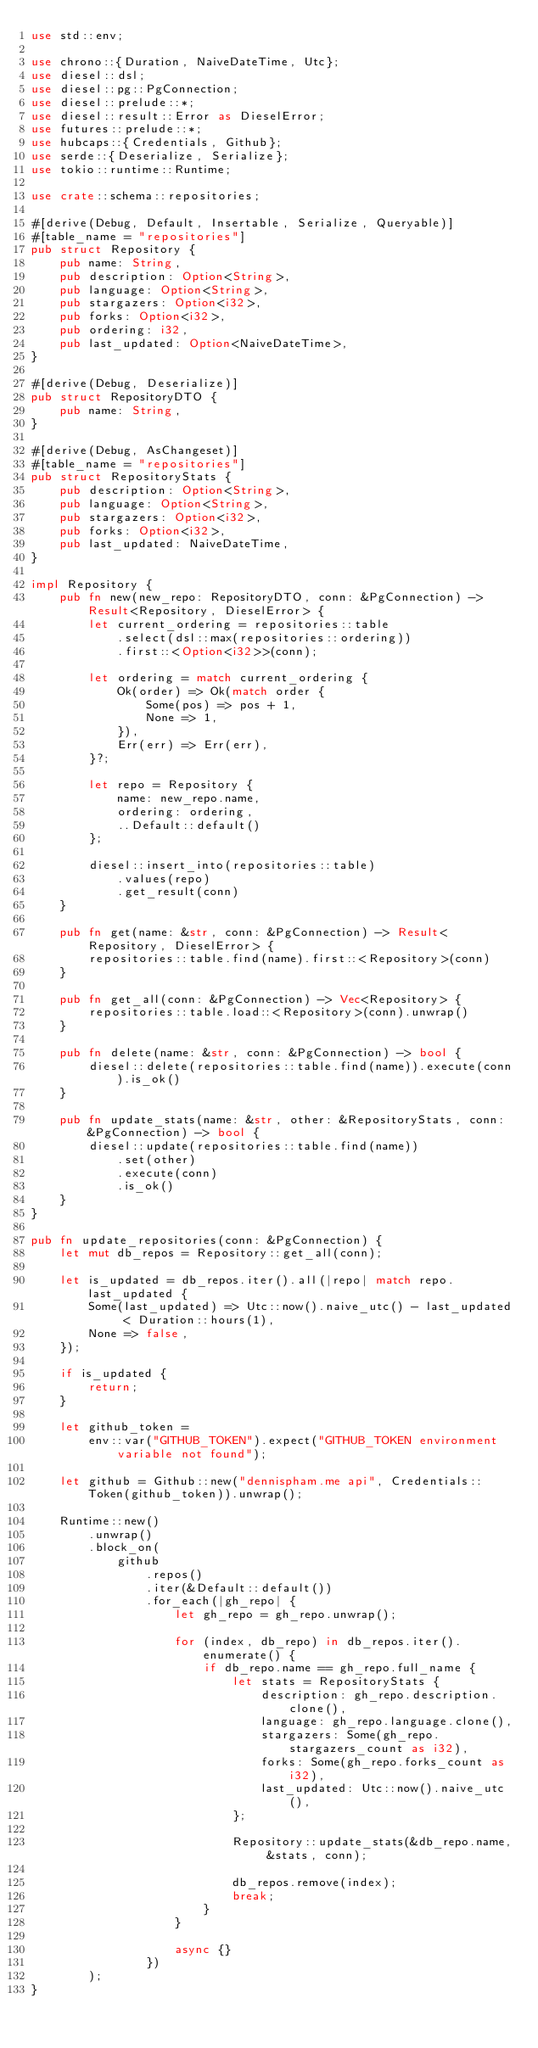<code> <loc_0><loc_0><loc_500><loc_500><_Rust_>use std::env;

use chrono::{Duration, NaiveDateTime, Utc};
use diesel::dsl;
use diesel::pg::PgConnection;
use diesel::prelude::*;
use diesel::result::Error as DieselError;
use futures::prelude::*;
use hubcaps::{Credentials, Github};
use serde::{Deserialize, Serialize};
use tokio::runtime::Runtime;

use crate::schema::repositories;

#[derive(Debug, Default, Insertable, Serialize, Queryable)]
#[table_name = "repositories"]
pub struct Repository {
    pub name: String,
    pub description: Option<String>,
    pub language: Option<String>,
    pub stargazers: Option<i32>,
    pub forks: Option<i32>,
    pub ordering: i32,
    pub last_updated: Option<NaiveDateTime>,
}

#[derive(Debug, Deserialize)]
pub struct RepositoryDTO {
    pub name: String,
}

#[derive(Debug, AsChangeset)]
#[table_name = "repositories"]
pub struct RepositoryStats {
    pub description: Option<String>,
    pub language: Option<String>,
    pub stargazers: Option<i32>,
    pub forks: Option<i32>,
    pub last_updated: NaiveDateTime,
}

impl Repository {
    pub fn new(new_repo: RepositoryDTO, conn: &PgConnection) -> Result<Repository, DieselError> {
        let current_ordering = repositories::table
            .select(dsl::max(repositories::ordering))
            .first::<Option<i32>>(conn);

        let ordering = match current_ordering {
            Ok(order) => Ok(match order {
                Some(pos) => pos + 1,
                None => 1,
            }),
            Err(err) => Err(err),
        }?;

        let repo = Repository {
            name: new_repo.name,
            ordering: ordering,
            ..Default::default()
        };

        diesel::insert_into(repositories::table)
            .values(repo)
            .get_result(conn)
    }

    pub fn get(name: &str, conn: &PgConnection) -> Result<Repository, DieselError> {
        repositories::table.find(name).first::<Repository>(conn)
    }

    pub fn get_all(conn: &PgConnection) -> Vec<Repository> {
        repositories::table.load::<Repository>(conn).unwrap()
    }

    pub fn delete(name: &str, conn: &PgConnection) -> bool {
        diesel::delete(repositories::table.find(name)).execute(conn).is_ok()
    }

    pub fn update_stats(name: &str, other: &RepositoryStats, conn: &PgConnection) -> bool {
        diesel::update(repositories::table.find(name))
            .set(other)
            .execute(conn)
            .is_ok()
    }
}

pub fn update_repositories(conn: &PgConnection) {
    let mut db_repos = Repository::get_all(conn);

    let is_updated = db_repos.iter().all(|repo| match repo.last_updated {
        Some(last_updated) => Utc::now().naive_utc() - last_updated < Duration::hours(1),
        None => false,
    });

    if is_updated {
        return;
    }

    let github_token =
        env::var("GITHUB_TOKEN").expect("GITHUB_TOKEN environment variable not found");

    let github = Github::new("dennispham.me api", Credentials::Token(github_token)).unwrap();

    Runtime::new()
        .unwrap()
        .block_on(
            github
                .repos()
                .iter(&Default::default())
                .for_each(|gh_repo| {
                    let gh_repo = gh_repo.unwrap();

                    for (index, db_repo) in db_repos.iter().enumerate() {
                        if db_repo.name == gh_repo.full_name {
                            let stats = RepositoryStats {
                                description: gh_repo.description.clone(),
                                language: gh_repo.language.clone(),
                                stargazers: Some(gh_repo.stargazers_count as i32),
                                forks: Some(gh_repo.forks_count as i32),
                                last_updated: Utc::now().naive_utc(),
                            };

                            Repository::update_stats(&db_repo.name, &stats, conn);

                            db_repos.remove(index);
                            break;
                        }
                    }

                    async {}
                })
        );
}
</code> 